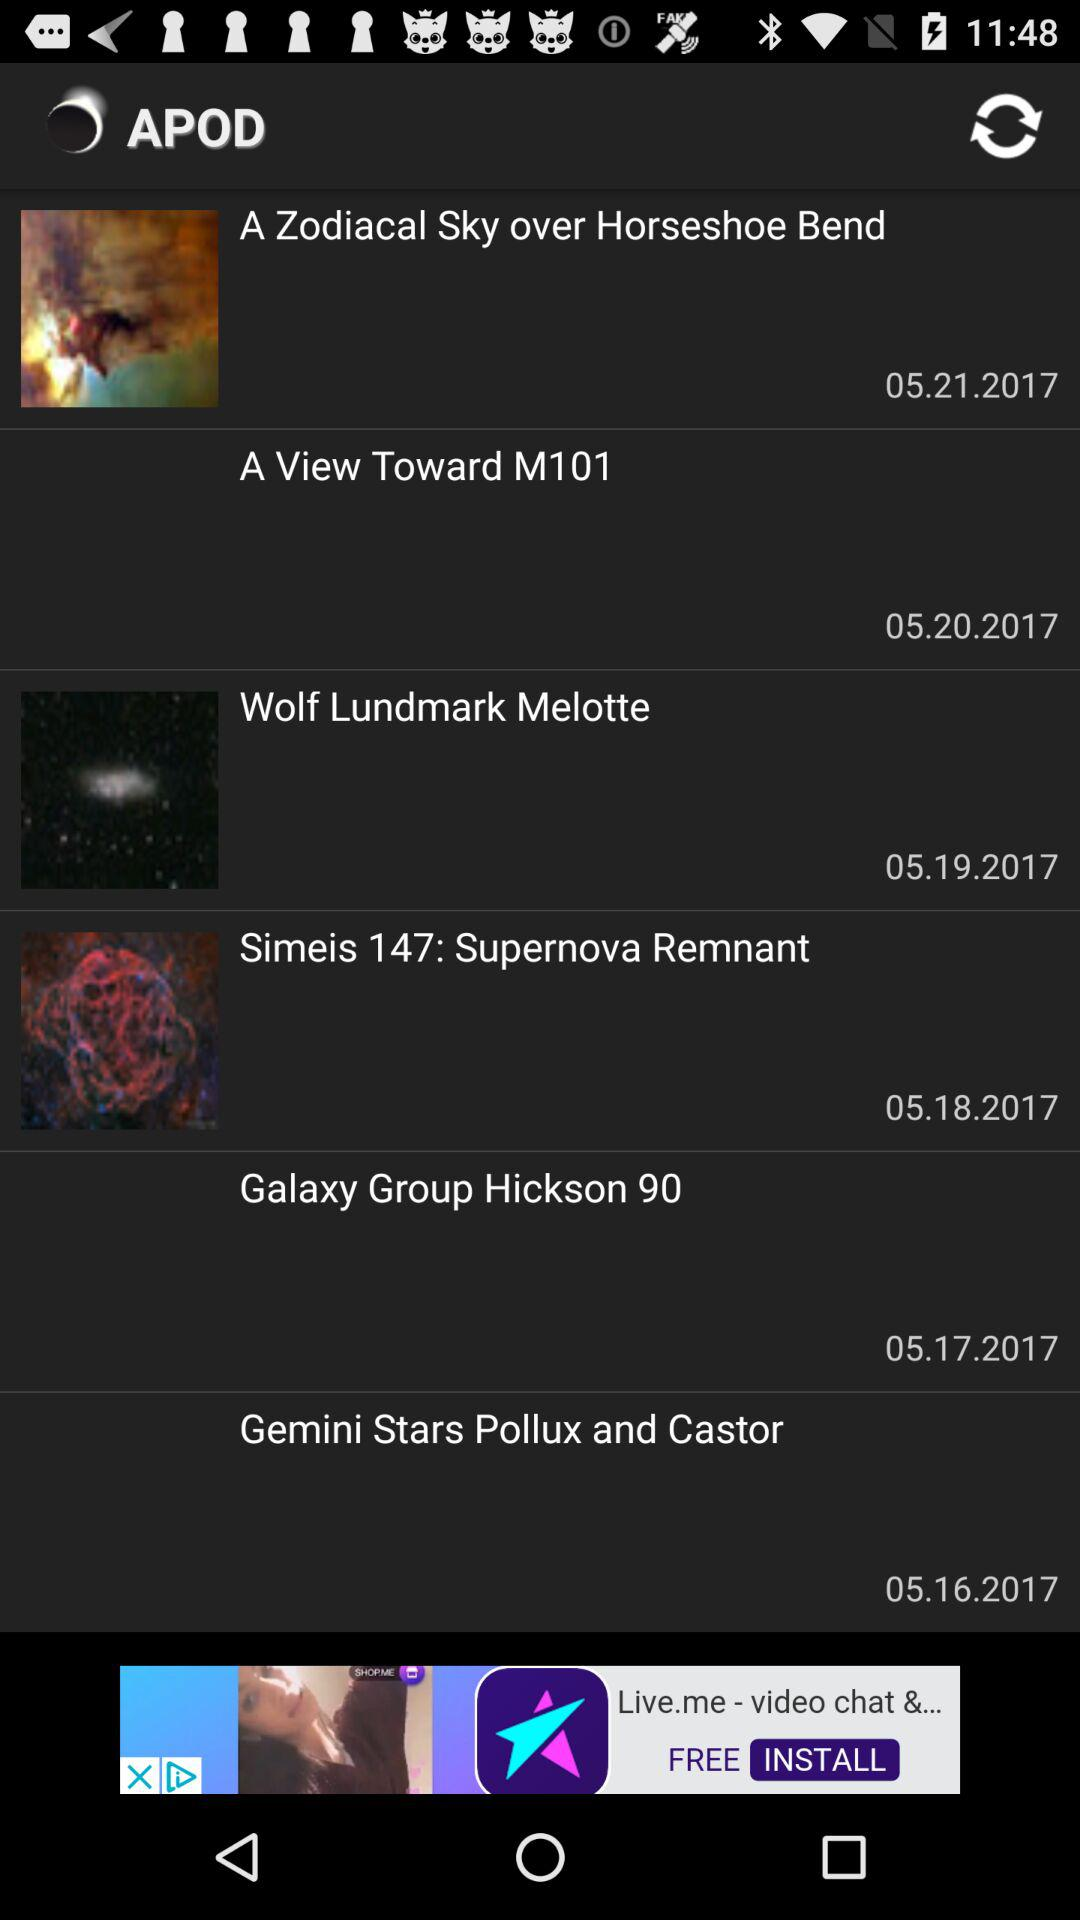What is the date for "Wolf Lundmark Melotte"? The date is May 19, 2017. 